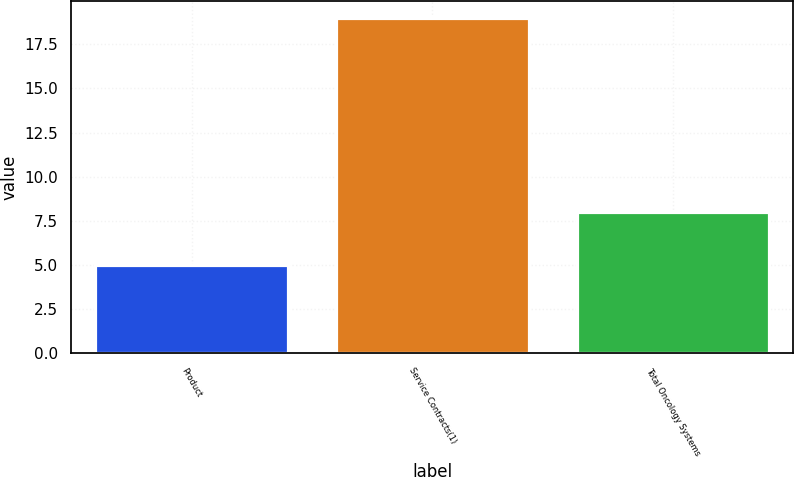<chart> <loc_0><loc_0><loc_500><loc_500><bar_chart><fcel>Product<fcel>Service Contracts(1)<fcel>Total Oncology Systems<nl><fcel>5<fcel>19<fcel>8<nl></chart> 